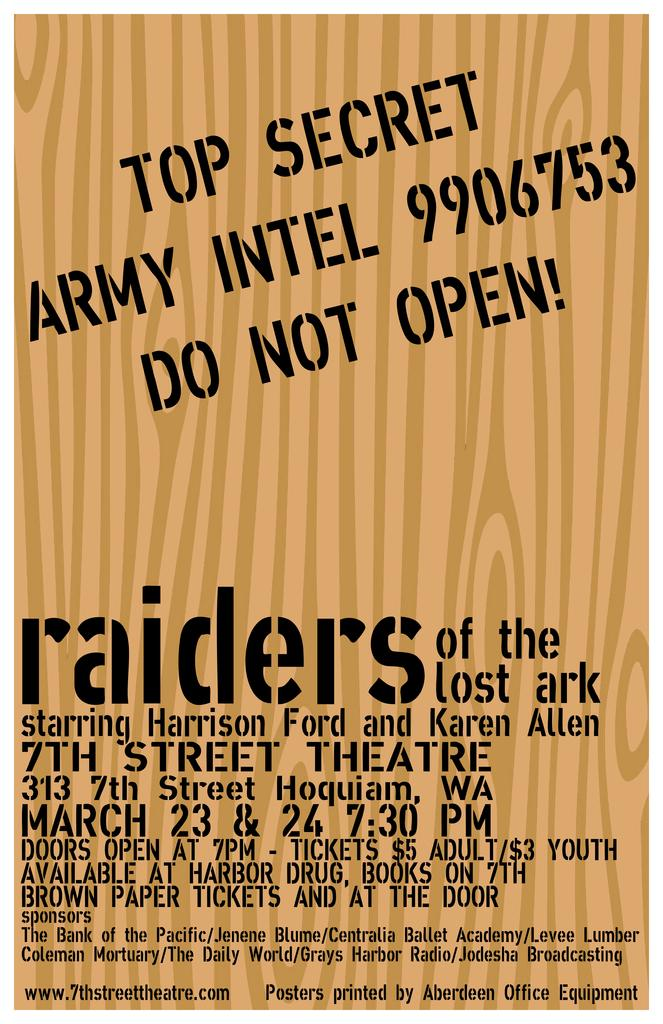<image>
Write a terse but informative summary of the picture. Here we have a poster that resembles a top secret Army intel file that advertises the movie Raiders of the Lost Ark. 